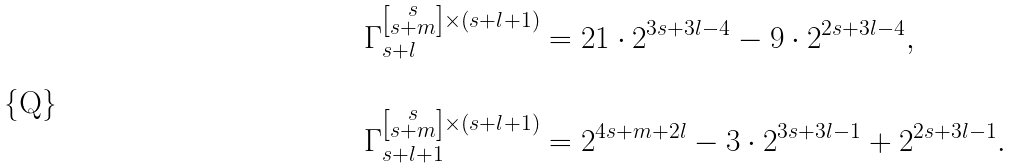Convert formula to latex. <formula><loc_0><loc_0><loc_500><loc_500>\Gamma _ { s + l } ^ { \left [ \substack { s \\ s + m } \right ] \times ( s + l + 1 ) } & = 2 1 \cdot 2 ^ { 3 s + 3 l - 4 } - 9 \cdot 2 ^ { 2 s + 3 l - 4 } , \\ & \\ \Gamma _ { s + l + 1 } ^ { \left [ \substack { s \\ s + m } \right ] \times ( s + l + 1 ) } & = 2 ^ { 4 s + m + 2 l } - 3 \cdot 2 ^ { 3 s + 3 l - 1 } + 2 ^ { 2 s + 3 l - 1 } . \\ &</formula> 